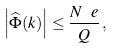Convert formula to latex. <formula><loc_0><loc_0><loc_500><loc_500>\left | \widehat { \Phi } ( k ) \right | \leq \frac { N ^ { \ } e } { Q } \, ,</formula> 